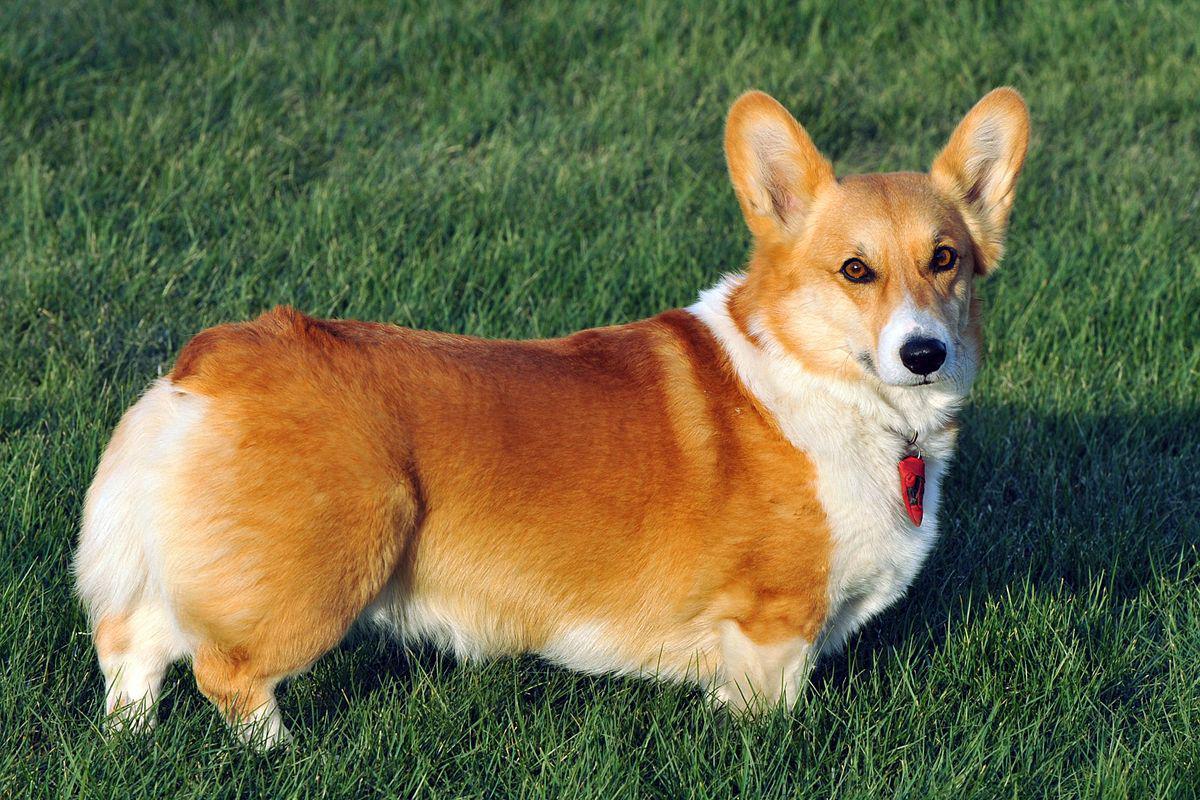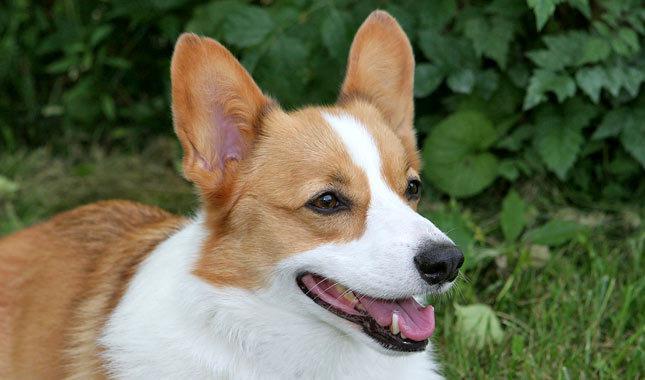The first image is the image on the left, the second image is the image on the right. Examine the images to the left and right. Is the description "The dog in the left image is brown/red and white; there is no black in the fur." accurate? Answer yes or no. Yes. The first image is the image on the left, the second image is the image on the right. For the images displayed, is the sentence "In one image, the dog is not on green grass." factually correct? Answer yes or no. No. The first image is the image on the left, the second image is the image on the right. Considering the images on both sides, is "An image includes an orange-and-white dog walking toward the camera on grass." valid? Answer yes or no. No. The first image is the image on the left, the second image is the image on the right. Given the left and right images, does the statement "At least one dog has it's head facing toward the left side of the image." hold true? Answer yes or no. No. 